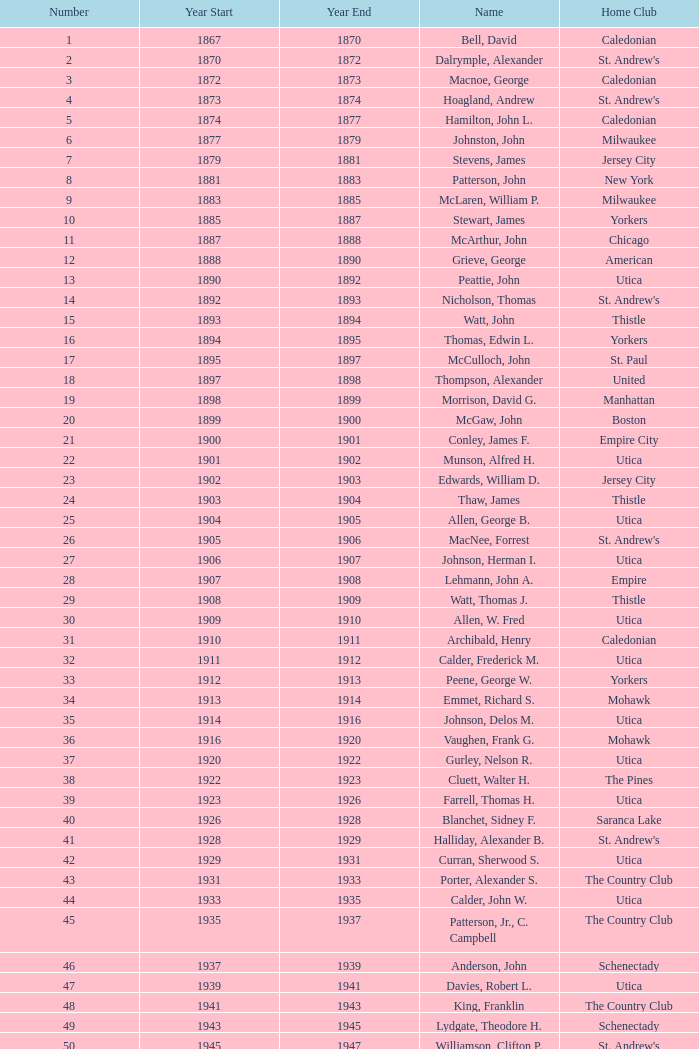What numeral is associated with hill, lucius t.? 53.0. 